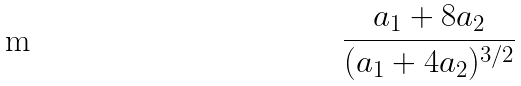<formula> <loc_0><loc_0><loc_500><loc_500>\frac { a _ { 1 } + 8 a _ { 2 } } { ( a _ { 1 } + 4 a _ { 2 } ) ^ { 3 / 2 } }</formula> 